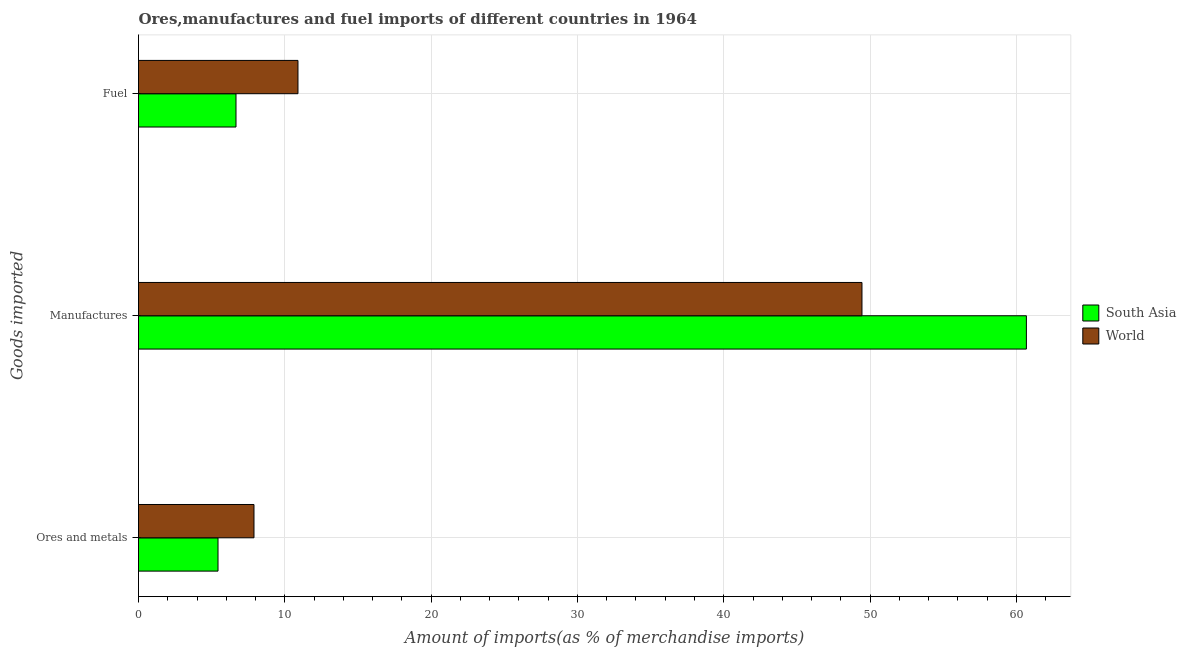How many different coloured bars are there?
Your answer should be very brief. 2. How many bars are there on the 1st tick from the top?
Your answer should be compact. 2. What is the label of the 3rd group of bars from the top?
Your answer should be very brief. Ores and metals. What is the percentage of manufactures imports in South Asia?
Offer a very short reply. 60.69. Across all countries, what is the maximum percentage of ores and metals imports?
Offer a terse response. 7.89. Across all countries, what is the minimum percentage of manufactures imports?
Provide a short and direct response. 49.45. In which country was the percentage of ores and metals imports maximum?
Keep it short and to the point. World. In which country was the percentage of ores and metals imports minimum?
Make the answer very short. South Asia. What is the total percentage of manufactures imports in the graph?
Your response must be concise. 110.14. What is the difference between the percentage of manufactures imports in World and that in South Asia?
Offer a terse response. -11.24. What is the difference between the percentage of manufactures imports in World and the percentage of ores and metals imports in South Asia?
Your response must be concise. 44.01. What is the average percentage of ores and metals imports per country?
Offer a very short reply. 6.66. What is the difference between the percentage of manufactures imports and percentage of ores and metals imports in South Asia?
Keep it short and to the point. 55.25. In how many countries, is the percentage of manufactures imports greater than 30 %?
Keep it short and to the point. 2. What is the ratio of the percentage of manufactures imports in World to that in South Asia?
Your response must be concise. 0.81. What is the difference between the highest and the second highest percentage of fuel imports?
Offer a very short reply. 4.24. What is the difference between the highest and the lowest percentage of manufactures imports?
Give a very brief answer. 11.24. In how many countries, is the percentage of fuel imports greater than the average percentage of fuel imports taken over all countries?
Keep it short and to the point. 1. What does the 2nd bar from the top in Ores and metals represents?
Keep it short and to the point. South Asia. How many bars are there?
Provide a short and direct response. 6. Are all the bars in the graph horizontal?
Ensure brevity in your answer.  Yes. Are the values on the major ticks of X-axis written in scientific E-notation?
Keep it short and to the point. No. Does the graph contain any zero values?
Keep it short and to the point. No. How many legend labels are there?
Provide a short and direct response. 2. What is the title of the graph?
Offer a terse response. Ores,manufactures and fuel imports of different countries in 1964. What is the label or title of the X-axis?
Your answer should be compact. Amount of imports(as % of merchandise imports). What is the label or title of the Y-axis?
Offer a terse response. Goods imported. What is the Amount of imports(as % of merchandise imports) of South Asia in Ores and metals?
Offer a very short reply. 5.43. What is the Amount of imports(as % of merchandise imports) of World in Ores and metals?
Your response must be concise. 7.89. What is the Amount of imports(as % of merchandise imports) of South Asia in Manufactures?
Keep it short and to the point. 60.69. What is the Amount of imports(as % of merchandise imports) in World in Manufactures?
Provide a short and direct response. 49.45. What is the Amount of imports(as % of merchandise imports) in South Asia in Fuel?
Your answer should be compact. 6.66. What is the Amount of imports(as % of merchandise imports) of World in Fuel?
Provide a succinct answer. 10.9. Across all Goods imported, what is the maximum Amount of imports(as % of merchandise imports) of South Asia?
Make the answer very short. 60.69. Across all Goods imported, what is the maximum Amount of imports(as % of merchandise imports) of World?
Your answer should be very brief. 49.45. Across all Goods imported, what is the minimum Amount of imports(as % of merchandise imports) of South Asia?
Provide a short and direct response. 5.43. Across all Goods imported, what is the minimum Amount of imports(as % of merchandise imports) in World?
Your answer should be very brief. 7.89. What is the total Amount of imports(as % of merchandise imports) of South Asia in the graph?
Your answer should be compact. 72.79. What is the total Amount of imports(as % of merchandise imports) in World in the graph?
Offer a very short reply. 68.24. What is the difference between the Amount of imports(as % of merchandise imports) in South Asia in Ores and metals and that in Manufactures?
Ensure brevity in your answer.  -55.25. What is the difference between the Amount of imports(as % of merchandise imports) of World in Ores and metals and that in Manufactures?
Make the answer very short. -41.56. What is the difference between the Amount of imports(as % of merchandise imports) in South Asia in Ores and metals and that in Fuel?
Keep it short and to the point. -1.23. What is the difference between the Amount of imports(as % of merchandise imports) of World in Ores and metals and that in Fuel?
Your answer should be very brief. -3.01. What is the difference between the Amount of imports(as % of merchandise imports) in South Asia in Manufactures and that in Fuel?
Your answer should be very brief. 54.02. What is the difference between the Amount of imports(as % of merchandise imports) in World in Manufactures and that in Fuel?
Offer a very short reply. 38.55. What is the difference between the Amount of imports(as % of merchandise imports) of South Asia in Ores and metals and the Amount of imports(as % of merchandise imports) of World in Manufactures?
Give a very brief answer. -44.01. What is the difference between the Amount of imports(as % of merchandise imports) of South Asia in Ores and metals and the Amount of imports(as % of merchandise imports) of World in Fuel?
Your response must be concise. -5.46. What is the difference between the Amount of imports(as % of merchandise imports) of South Asia in Manufactures and the Amount of imports(as % of merchandise imports) of World in Fuel?
Keep it short and to the point. 49.79. What is the average Amount of imports(as % of merchandise imports) of South Asia per Goods imported?
Offer a terse response. 24.26. What is the average Amount of imports(as % of merchandise imports) of World per Goods imported?
Give a very brief answer. 22.75. What is the difference between the Amount of imports(as % of merchandise imports) of South Asia and Amount of imports(as % of merchandise imports) of World in Ores and metals?
Your answer should be compact. -2.46. What is the difference between the Amount of imports(as % of merchandise imports) of South Asia and Amount of imports(as % of merchandise imports) of World in Manufactures?
Your answer should be compact. 11.24. What is the difference between the Amount of imports(as % of merchandise imports) in South Asia and Amount of imports(as % of merchandise imports) in World in Fuel?
Your response must be concise. -4.24. What is the ratio of the Amount of imports(as % of merchandise imports) in South Asia in Ores and metals to that in Manufactures?
Provide a succinct answer. 0.09. What is the ratio of the Amount of imports(as % of merchandise imports) in World in Ores and metals to that in Manufactures?
Provide a succinct answer. 0.16. What is the ratio of the Amount of imports(as % of merchandise imports) of South Asia in Ores and metals to that in Fuel?
Your answer should be very brief. 0.82. What is the ratio of the Amount of imports(as % of merchandise imports) of World in Ores and metals to that in Fuel?
Your answer should be very brief. 0.72. What is the ratio of the Amount of imports(as % of merchandise imports) of South Asia in Manufactures to that in Fuel?
Your answer should be very brief. 9.11. What is the ratio of the Amount of imports(as % of merchandise imports) in World in Manufactures to that in Fuel?
Ensure brevity in your answer.  4.54. What is the difference between the highest and the second highest Amount of imports(as % of merchandise imports) of South Asia?
Provide a succinct answer. 54.02. What is the difference between the highest and the second highest Amount of imports(as % of merchandise imports) of World?
Your answer should be compact. 38.55. What is the difference between the highest and the lowest Amount of imports(as % of merchandise imports) in South Asia?
Your response must be concise. 55.25. What is the difference between the highest and the lowest Amount of imports(as % of merchandise imports) of World?
Your response must be concise. 41.56. 